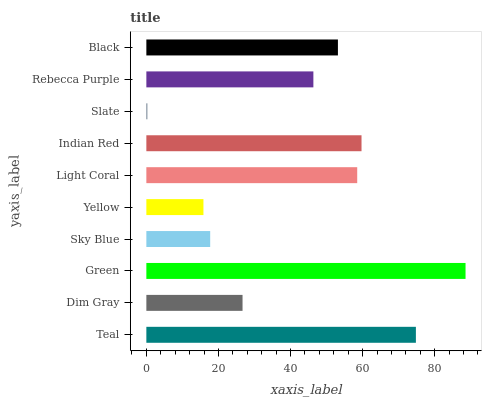Is Slate the minimum?
Answer yes or no. Yes. Is Green the maximum?
Answer yes or no. Yes. Is Dim Gray the minimum?
Answer yes or no. No. Is Dim Gray the maximum?
Answer yes or no. No. Is Teal greater than Dim Gray?
Answer yes or no. Yes. Is Dim Gray less than Teal?
Answer yes or no. Yes. Is Dim Gray greater than Teal?
Answer yes or no. No. Is Teal less than Dim Gray?
Answer yes or no. No. Is Black the high median?
Answer yes or no. Yes. Is Rebecca Purple the low median?
Answer yes or no. Yes. Is Indian Red the high median?
Answer yes or no. No. Is Dim Gray the low median?
Answer yes or no. No. 